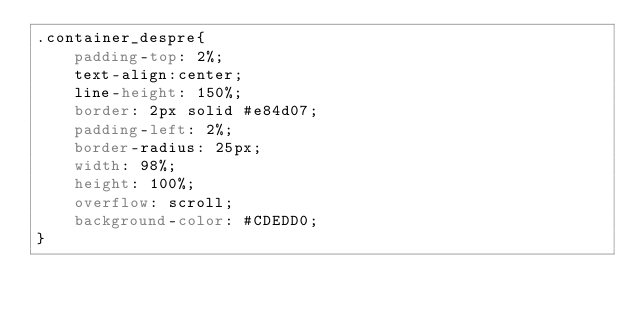Convert code to text. <code><loc_0><loc_0><loc_500><loc_500><_CSS_>.container_despre{
    padding-top: 2%;
    text-align:center;
    line-height: 150%;
    border: 2px solid #e84d07;
    padding-left: 2%;
    border-radius: 25px;
    width: 98%;
    height: 100%;
    overflow: scroll;
    background-color: #CDEDD0;
}
</code> 